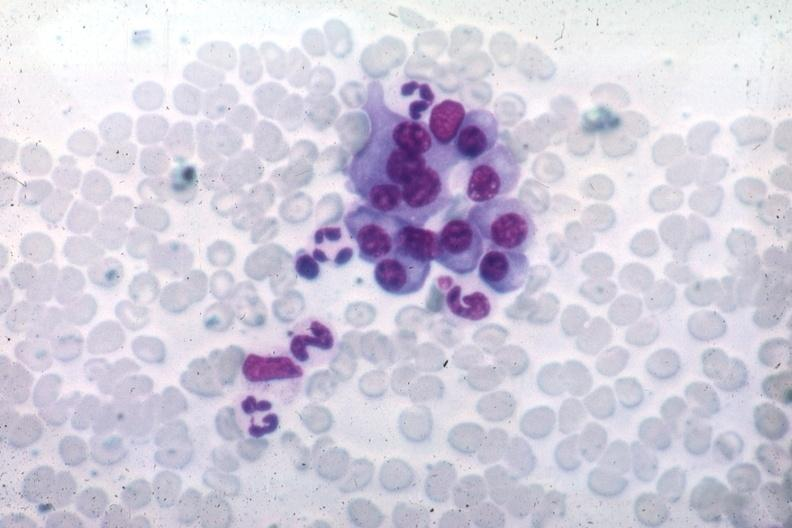s cytomegaly present?
Answer the question using a single word or phrase. No 